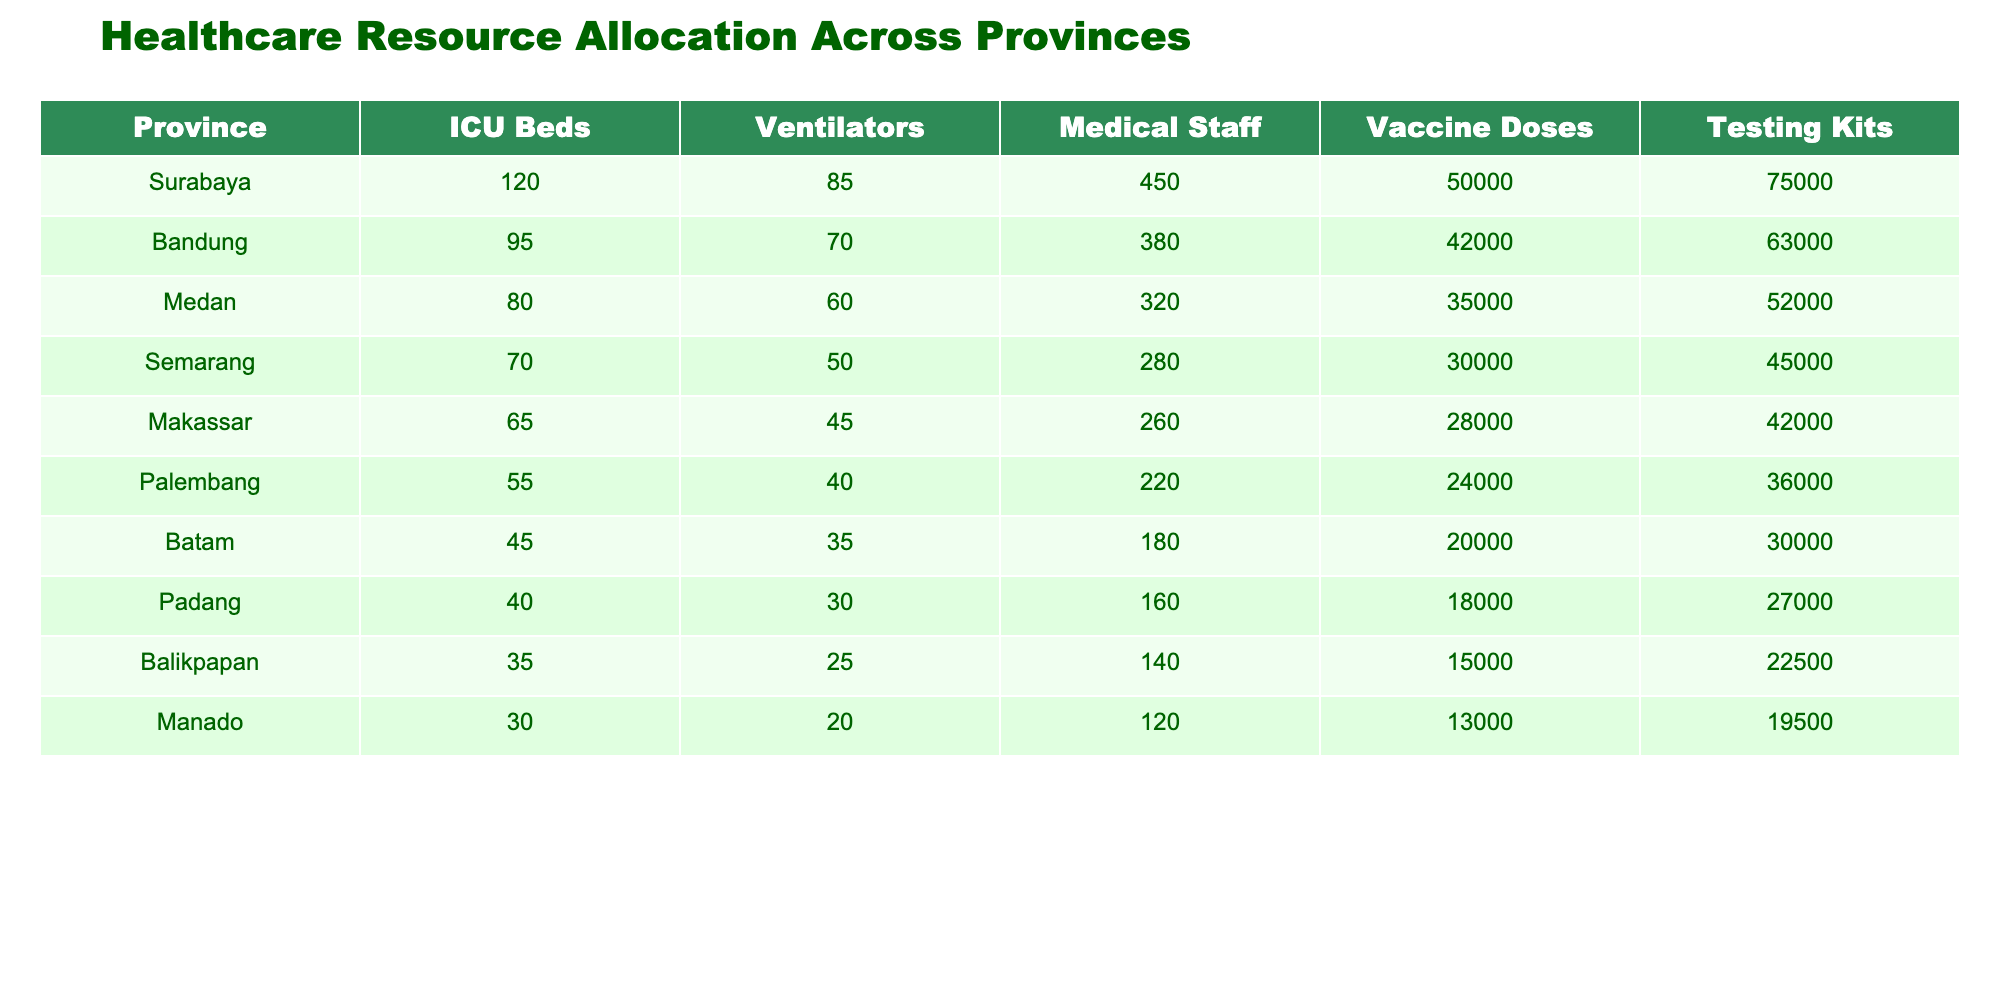What province has the highest number of ICU beds? Looking at the "ICU Beds" column, Surabaya has 120 ICU beds, which is greater than all other provinces listed.
Answer: Surabaya What is the total number of ventilators available across all provinces? To find the total, we add the ventilators: 85 + 70 + 60 + 50 + 45 + 40 + 35 + 30 + 25 + 20 = 510.
Answer: 510 Which province has the least number of medical staff? By comparing the "Medical Staff" numbers, Batam has the least at 180, which is lower than the medical staff numbers in all other provinces.
Answer: Batam Is there a province with more vaccine doses than ICU beds? By comparing the columns, Surabaya (50,000 doses vs. 120 beds), Bandung (42,000 doses vs. 95 beds), and others show higher vaccine doses than ICU beds. So, yes, several provinces meet this criterion.
Answer: Yes What is the average number of testing kits per province? To find the average, add the testing kits (75,000 + 63,000 + 52,000 + 45,000 + 42,000 + 36,000 + 30,000 + 27,000 + 22,500 + 19,500 =  450,000), then divide by the number of provinces (450,000 / 10 = 45,000).
Answer: 45,000 Which provinces have more than 70 ICU beds? By examining the "ICU Beds" column, Surabaya (120), Bandung (95), and Medan (80) all have more than 70 ICU beds.
Answer: Surabaya, Bandung, Medan How many more vaccine doses does Surabaya have compared to Palembang? Subtract the vaccine doses of Palembang (24,000) from Surabaya (50,000): 50,000 - 24,000 = 26,000.
Answer: 26,000 Is Palembang equipped with more ventilators than Makassar? Comparing the "Ventilators" columns, Palembang has 40 while Makassar has 45, hence Palembang has fewer ventilators.
Answer: No What is the difference in the number of medical staff between Bandung and Balikpapan? The number of medical staff in Bandung is 380 and in Balikpapan is 140. The difference is 380 - 140 = 240.
Answer: 240 Which province has the highest ratio of vaccine doses to medical staff? Calculating the ratio for each province, Surabaya has 50000/450 = 111.11, Bandung has 42000/380 = 110.53, and the ratios decrease down the list. Surabaya has the highest ratio.
Answer: Surabaya 